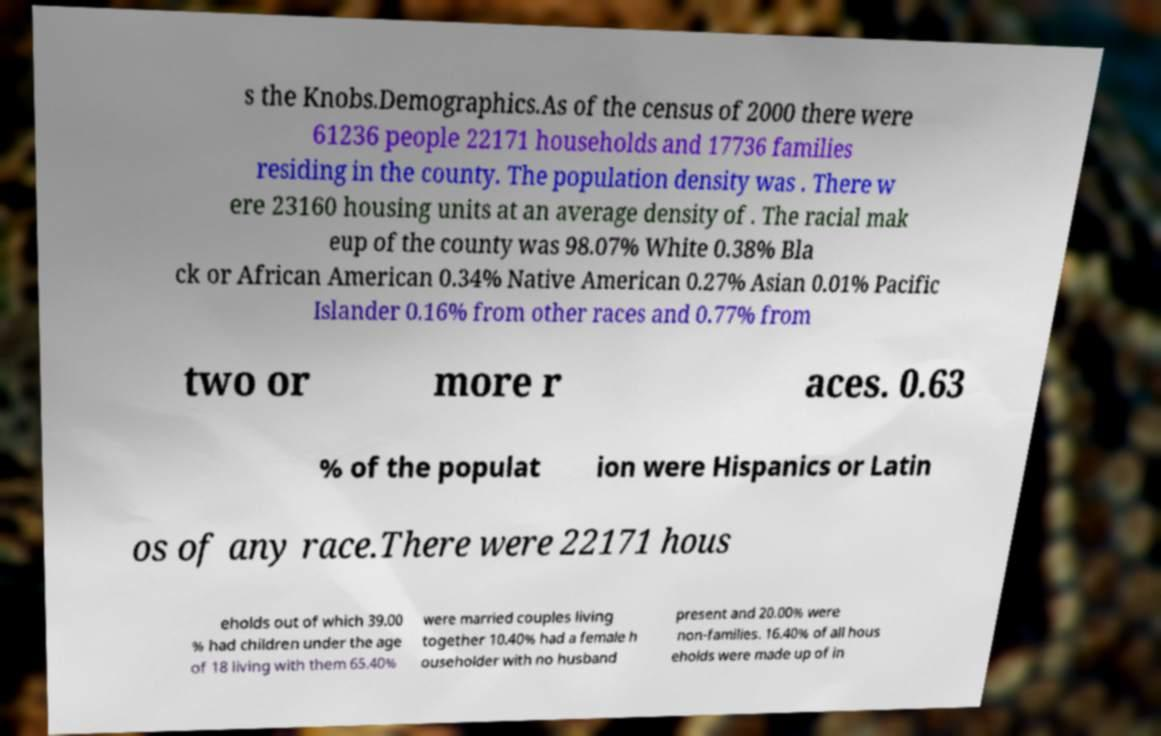What messages or text are displayed in this image? I need them in a readable, typed format. s the Knobs.Demographics.As of the census of 2000 there were 61236 people 22171 households and 17736 families residing in the county. The population density was . There w ere 23160 housing units at an average density of . The racial mak eup of the county was 98.07% White 0.38% Bla ck or African American 0.34% Native American 0.27% Asian 0.01% Pacific Islander 0.16% from other races and 0.77% from two or more r aces. 0.63 % of the populat ion were Hispanics or Latin os of any race.There were 22171 hous eholds out of which 39.00 % had children under the age of 18 living with them 65.40% were married couples living together 10.40% had a female h ouseholder with no husband present and 20.00% were non-families. 16.40% of all hous eholds were made up of in 